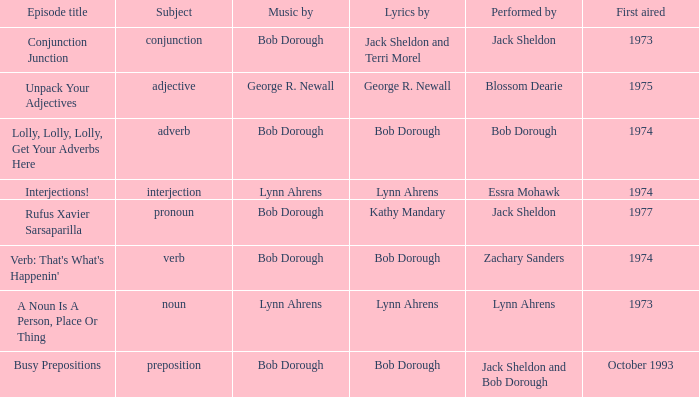When conjunction junction is the episode title and the music is by bob dorough who is the performer? Jack Sheldon. 